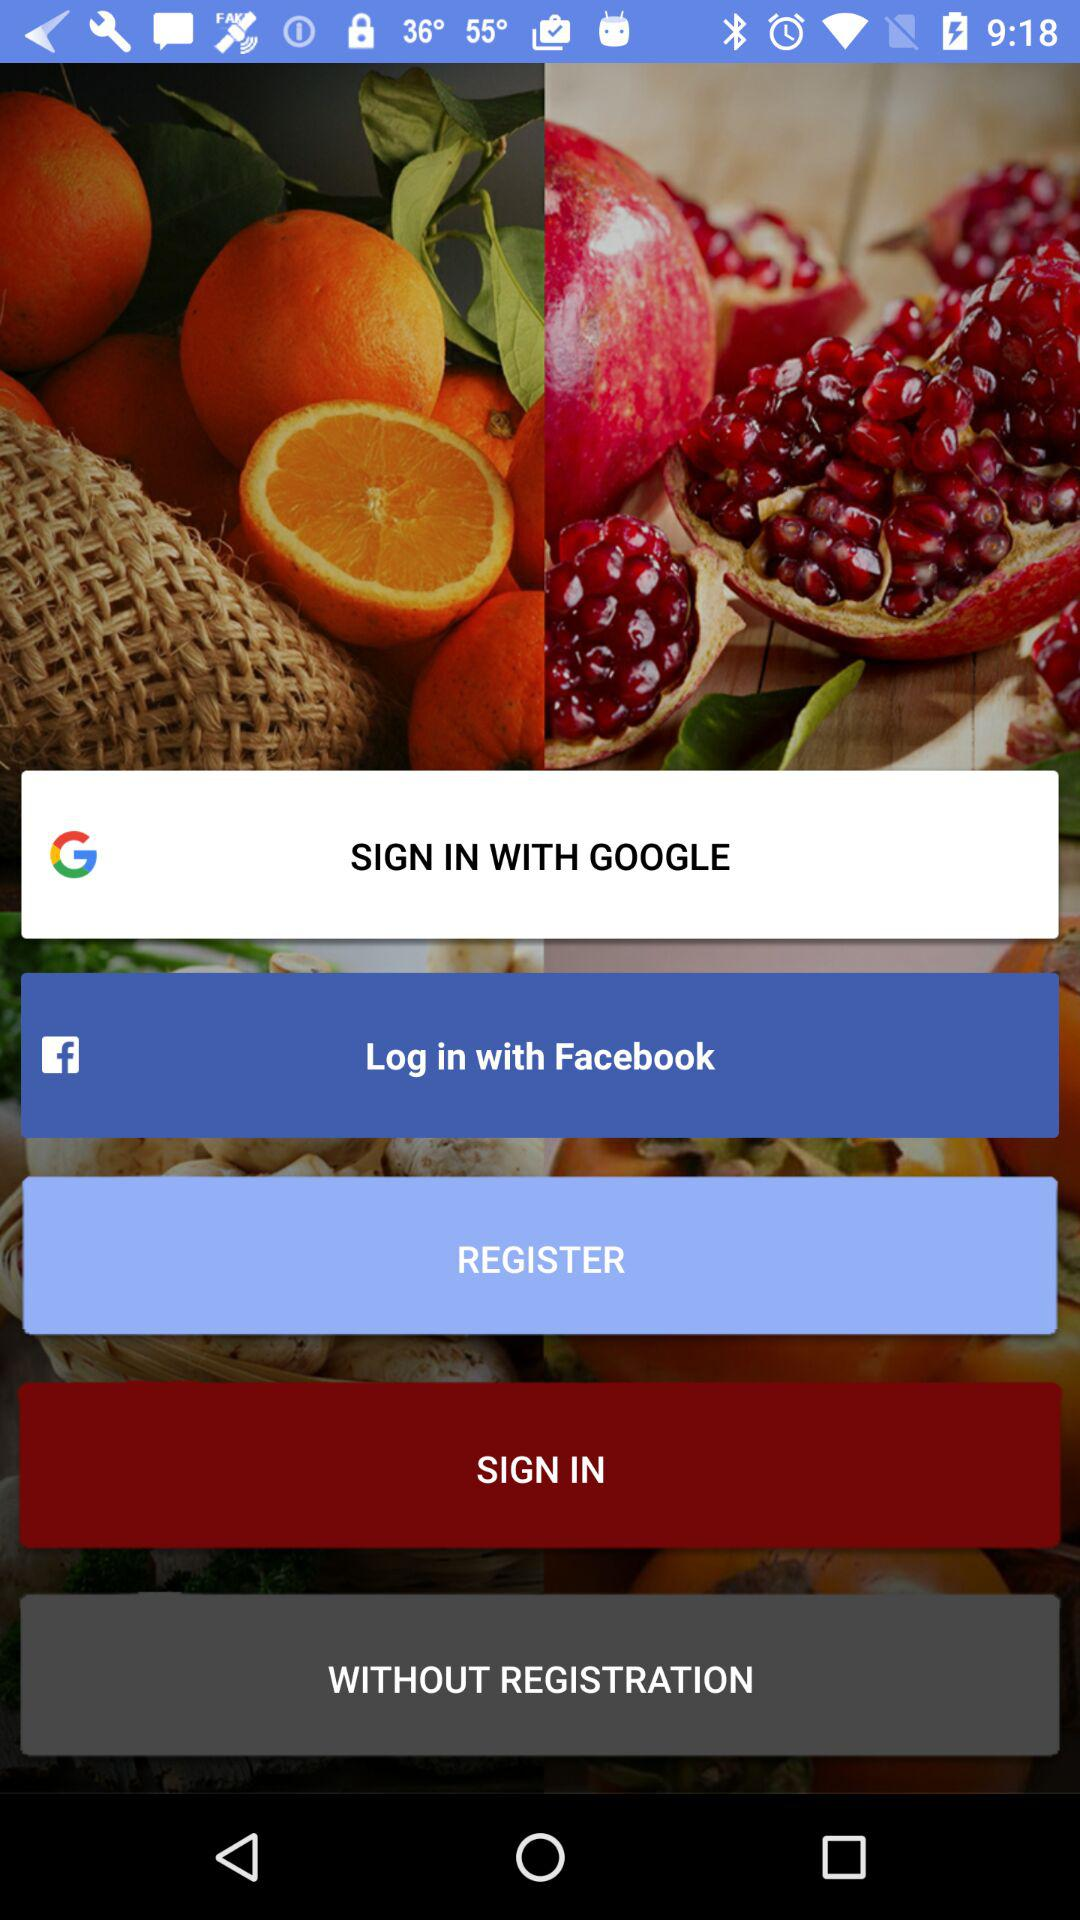What are the different options available for log in? The different options available for log in are "GOOGLE" and "Facebook". 